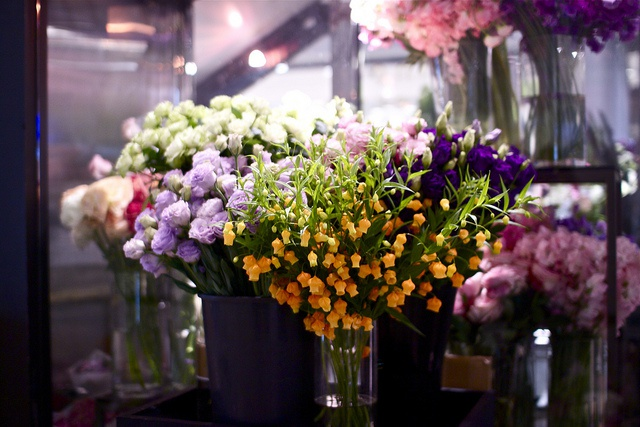Describe the objects in this image and their specific colors. I can see vase in black, gray, navy, and maroon tones, vase in black and gray tones, vase in black, gray, and darkgray tones, vase in black, purple, maroon, and darkgreen tones, and vase in black and gray tones in this image. 